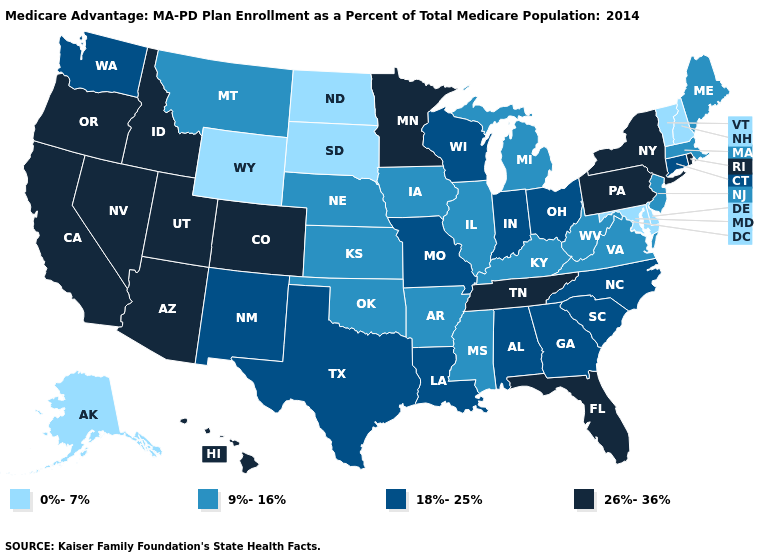What is the value of Louisiana?
Write a very short answer. 18%-25%. Which states hav the highest value in the MidWest?
Answer briefly. Minnesota. Name the states that have a value in the range 18%-25%?
Quick response, please. Alabama, Connecticut, Georgia, Indiana, Louisiana, Missouri, North Carolina, New Mexico, Ohio, South Carolina, Texas, Washington, Wisconsin. Does New Mexico have the highest value in the West?
Be succinct. No. Does Vermont have the highest value in the Northeast?
Short answer required. No. Among the states that border South Dakota , which have the highest value?
Be succinct. Minnesota. How many symbols are there in the legend?
Give a very brief answer. 4. What is the highest value in the USA?
Be succinct. 26%-36%. Does North Dakota have the highest value in the MidWest?
Give a very brief answer. No. What is the lowest value in the USA?
Give a very brief answer. 0%-7%. Which states have the lowest value in the USA?
Be succinct. Alaska, Delaware, Maryland, North Dakota, New Hampshire, South Dakota, Vermont, Wyoming. What is the highest value in states that border California?
Be succinct. 26%-36%. How many symbols are there in the legend?
Short answer required. 4. Name the states that have a value in the range 18%-25%?
Write a very short answer. Alabama, Connecticut, Georgia, Indiana, Louisiana, Missouri, North Carolina, New Mexico, Ohio, South Carolina, Texas, Washington, Wisconsin. What is the lowest value in the MidWest?
Write a very short answer. 0%-7%. 